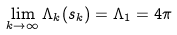<formula> <loc_0><loc_0><loc_500><loc_500>\lim _ { k \rightarrow \infty } \Lambda _ { k } ( s _ { k } ) = \Lambda _ { 1 } = 4 \pi</formula> 